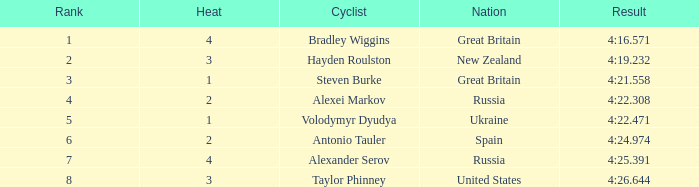What is the worst ranking spain has ever received? 6.0. 